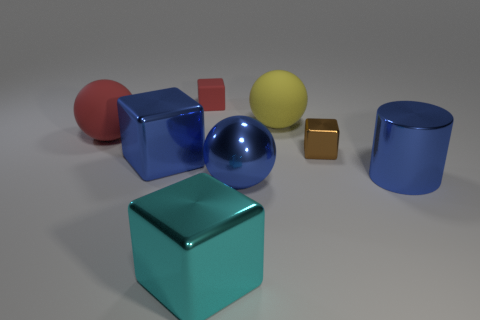Is the number of large blocks in front of the large blue metallic cylinder less than the number of cubes right of the tiny red rubber thing?
Your answer should be compact. Yes. What is the size of the brown metallic thing in front of the cube behind the large ball that is left of the blue block?
Your answer should be compact. Small. There is a blue thing that is to the left of the red rubber cube; does it have the same size as the small red thing?
Make the answer very short. No. How many other objects are the same material as the brown cube?
Keep it short and to the point. 4. Are there more big blue cylinders than small gray rubber blocks?
Give a very brief answer. Yes. There is a ball that is left of the blue object to the left of the big cube in front of the blue metallic sphere; what is it made of?
Ensure brevity in your answer.  Rubber. Does the large cylinder have the same color as the small metal thing?
Offer a terse response. No. Is there a object that has the same color as the matte block?
Offer a terse response. Yes. There is a cyan shiny object that is the same size as the blue cylinder; what shape is it?
Your answer should be compact. Cube. Are there fewer small objects than things?
Your answer should be compact. Yes. 